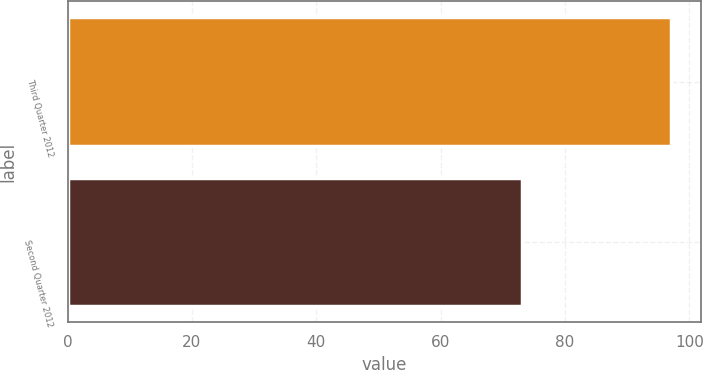Convert chart to OTSL. <chart><loc_0><loc_0><loc_500><loc_500><bar_chart><fcel>Third Quarter 2012<fcel>Second Quarter 2012<nl><fcel>97<fcel>73<nl></chart> 